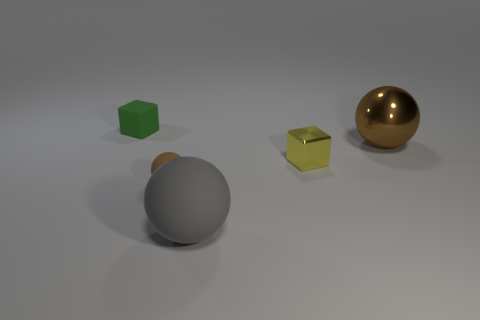What number of other things are there of the same size as the gray object? 1 